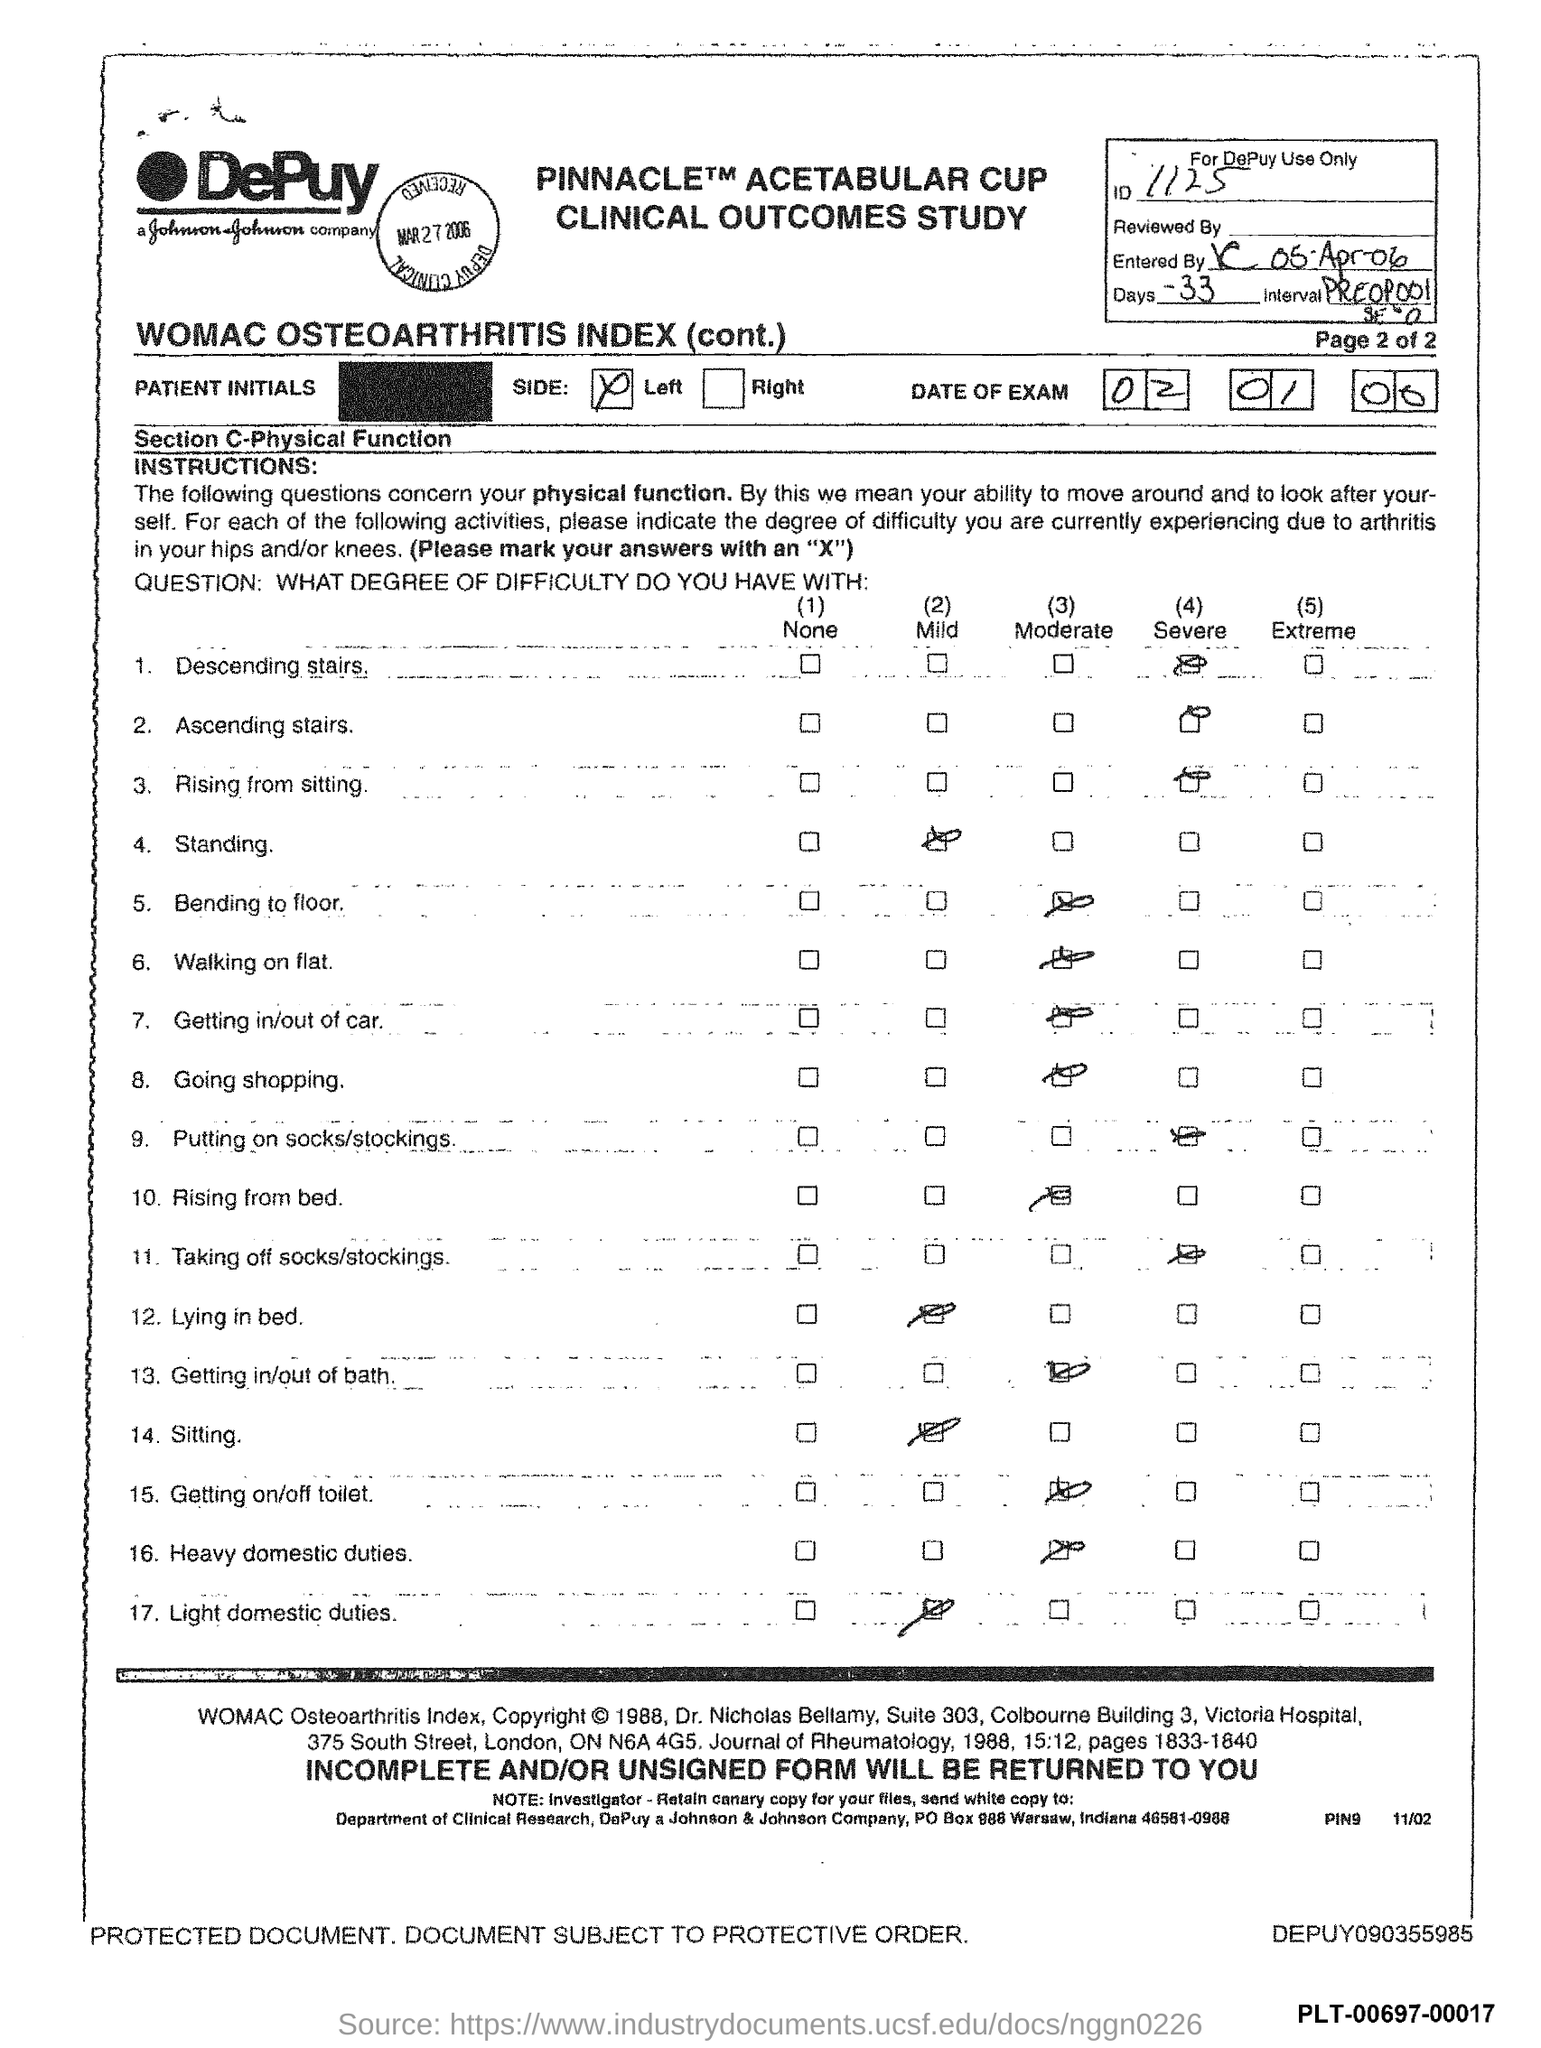List a handful of essential elements in this visual. What is the identification number? The number is 1125. The number of days is -33.. 